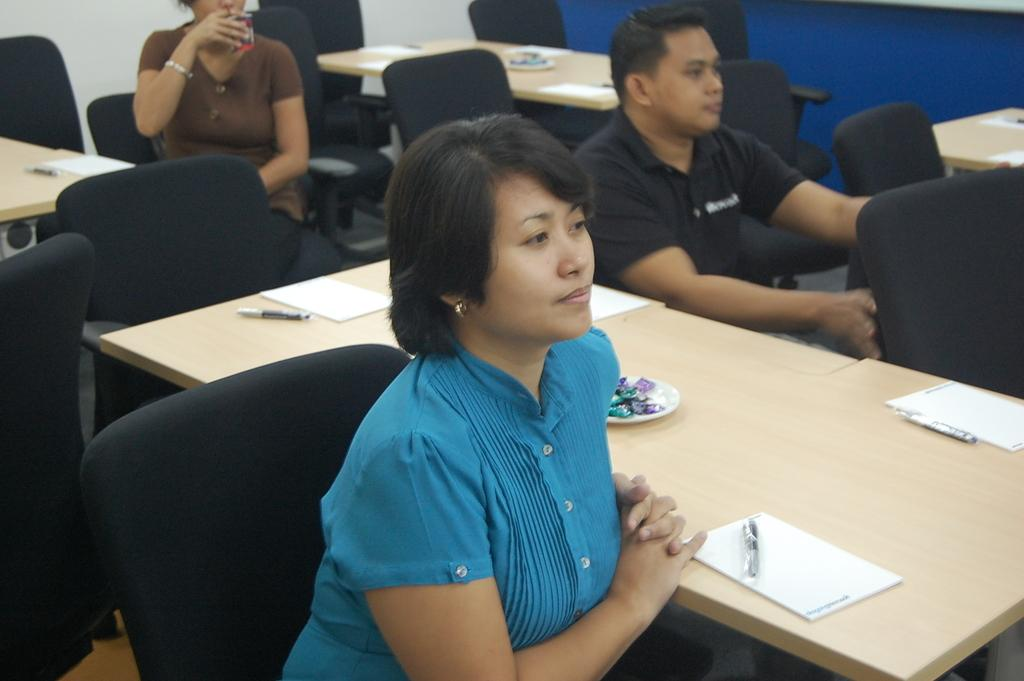How many people are in the image? There are three people in the image. What are the people doing in the image? The people are sitting in a black chair. What is located beside the people? There is a table beside the people. What can be seen on the table? The table has papers on it, and there are other objects on the table. What type of plant is growing on the table in the image? There is no plant visible on the table in the image. What kind of insurance policy is being discussed by the people in the image? There is no indication in the image that the people are discussing insurance. 